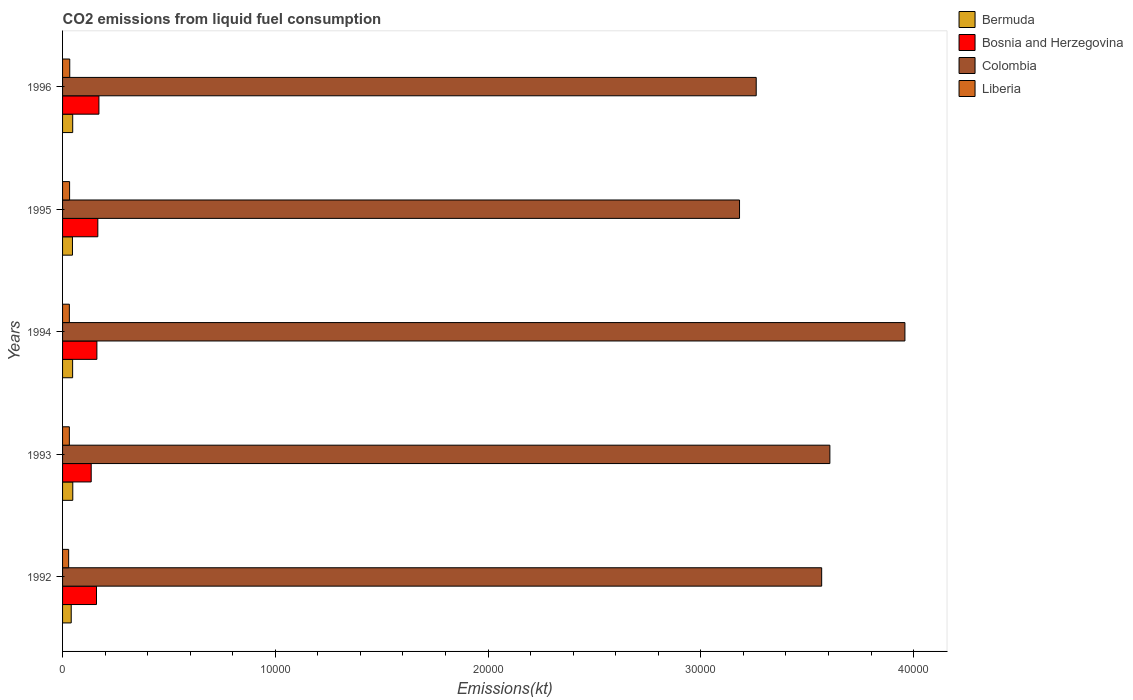How many different coloured bars are there?
Your answer should be compact. 4. How many groups of bars are there?
Your response must be concise. 5. Are the number of bars per tick equal to the number of legend labels?
Provide a succinct answer. Yes. Are the number of bars on each tick of the Y-axis equal?
Your answer should be very brief. Yes. How many bars are there on the 3rd tick from the bottom?
Provide a short and direct response. 4. What is the label of the 4th group of bars from the top?
Your response must be concise. 1993. In how many cases, is the number of bars for a given year not equal to the number of legend labels?
Your answer should be very brief. 0. What is the amount of CO2 emitted in Liberia in 1995?
Ensure brevity in your answer.  330.03. Across all years, what is the maximum amount of CO2 emitted in Colombia?
Give a very brief answer. 3.96e+04. Across all years, what is the minimum amount of CO2 emitted in Liberia?
Provide a succinct answer. 286.03. What is the total amount of CO2 emitted in Bermuda in the graph?
Give a very brief answer. 2302.88. What is the difference between the amount of CO2 emitted in Bermuda in 1994 and that in 1996?
Offer a very short reply. -3.67. What is the difference between the amount of CO2 emitted in Colombia in 1994 and the amount of CO2 emitted in Bosnia and Herzegovina in 1996?
Provide a short and direct response. 3.79e+04. What is the average amount of CO2 emitted in Liberia per year?
Your answer should be very brief. 318.3. In the year 1992, what is the difference between the amount of CO2 emitted in Bosnia and Herzegovina and amount of CO2 emitted in Liberia?
Offer a terse response. 1309.12. What is the ratio of the amount of CO2 emitted in Bosnia and Herzegovina in 1992 to that in 1994?
Offer a very short reply. 0.99. Is the amount of CO2 emitted in Liberia in 1993 less than that in 1996?
Ensure brevity in your answer.  Yes. Is the difference between the amount of CO2 emitted in Bosnia and Herzegovina in 1993 and 1994 greater than the difference between the amount of CO2 emitted in Liberia in 1993 and 1994?
Your response must be concise. No. What is the difference between the highest and the second highest amount of CO2 emitted in Colombia?
Make the answer very short. 3527.65. What is the difference between the highest and the lowest amount of CO2 emitted in Liberia?
Provide a short and direct response. 51.34. In how many years, is the amount of CO2 emitted in Liberia greater than the average amount of CO2 emitted in Liberia taken over all years?
Ensure brevity in your answer.  4. What does the 1st bar from the top in 1994 represents?
Your answer should be compact. Liberia. What does the 2nd bar from the bottom in 1993 represents?
Your answer should be compact. Bosnia and Herzegovina. How many bars are there?
Your answer should be very brief. 20. Are all the bars in the graph horizontal?
Provide a succinct answer. Yes. What is the difference between two consecutive major ticks on the X-axis?
Ensure brevity in your answer.  10000. Are the values on the major ticks of X-axis written in scientific E-notation?
Provide a succinct answer. No. Does the graph contain any zero values?
Your answer should be very brief. No. How are the legend labels stacked?
Offer a terse response. Vertical. What is the title of the graph?
Make the answer very short. CO2 emissions from liquid fuel consumption. Does "Togo" appear as one of the legend labels in the graph?
Offer a very short reply. No. What is the label or title of the X-axis?
Your response must be concise. Emissions(kt). What is the Emissions(kt) of Bermuda in 1992?
Offer a terse response. 407.04. What is the Emissions(kt) in Bosnia and Herzegovina in 1992?
Your answer should be compact. 1595.14. What is the Emissions(kt) of Colombia in 1992?
Keep it short and to the point. 3.57e+04. What is the Emissions(kt) of Liberia in 1992?
Ensure brevity in your answer.  286.03. What is the Emissions(kt) of Bermuda in 1993?
Your response must be concise. 480.38. What is the Emissions(kt) in Bosnia and Herzegovina in 1993?
Make the answer very short. 1345.79. What is the Emissions(kt) in Colombia in 1993?
Provide a short and direct response. 3.61e+04. What is the Emissions(kt) in Liberia in 1993?
Your response must be concise. 319.03. What is the Emissions(kt) of Bermuda in 1994?
Give a very brief answer. 473.04. What is the Emissions(kt) of Bosnia and Herzegovina in 1994?
Give a very brief answer. 1613.48. What is the Emissions(kt) in Colombia in 1994?
Offer a very short reply. 3.96e+04. What is the Emissions(kt) in Liberia in 1994?
Your answer should be compact. 319.03. What is the Emissions(kt) of Bermuda in 1995?
Provide a short and direct response. 465.71. What is the Emissions(kt) of Bosnia and Herzegovina in 1995?
Offer a very short reply. 1657.48. What is the Emissions(kt) of Colombia in 1995?
Provide a short and direct response. 3.18e+04. What is the Emissions(kt) in Liberia in 1995?
Make the answer very short. 330.03. What is the Emissions(kt) of Bermuda in 1996?
Make the answer very short. 476.71. What is the Emissions(kt) of Bosnia and Herzegovina in 1996?
Provide a short and direct response. 1708.82. What is the Emissions(kt) of Colombia in 1996?
Make the answer very short. 3.26e+04. What is the Emissions(kt) of Liberia in 1996?
Offer a terse response. 337.36. Across all years, what is the maximum Emissions(kt) of Bermuda?
Offer a terse response. 480.38. Across all years, what is the maximum Emissions(kt) of Bosnia and Herzegovina?
Keep it short and to the point. 1708.82. Across all years, what is the maximum Emissions(kt) in Colombia?
Ensure brevity in your answer.  3.96e+04. Across all years, what is the maximum Emissions(kt) in Liberia?
Provide a succinct answer. 337.36. Across all years, what is the minimum Emissions(kt) in Bermuda?
Provide a succinct answer. 407.04. Across all years, what is the minimum Emissions(kt) of Bosnia and Herzegovina?
Keep it short and to the point. 1345.79. Across all years, what is the minimum Emissions(kt) in Colombia?
Provide a succinct answer. 3.18e+04. Across all years, what is the minimum Emissions(kt) in Liberia?
Your answer should be very brief. 286.03. What is the total Emissions(kt) in Bermuda in the graph?
Provide a succinct answer. 2302.88. What is the total Emissions(kt) of Bosnia and Herzegovina in the graph?
Provide a succinct answer. 7920.72. What is the total Emissions(kt) of Colombia in the graph?
Offer a terse response. 1.76e+05. What is the total Emissions(kt) of Liberia in the graph?
Make the answer very short. 1591.48. What is the difference between the Emissions(kt) of Bermuda in 1992 and that in 1993?
Your response must be concise. -73.34. What is the difference between the Emissions(kt) of Bosnia and Herzegovina in 1992 and that in 1993?
Offer a very short reply. 249.36. What is the difference between the Emissions(kt) of Colombia in 1992 and that in 1993?
Your answer should be very brief. -385.04. What is the difference between the Emissions(kt) of Liberia in 1992 and that in 1993?
Your response must be concise. -33. What is the difference between the Emissions(kt) in Bermuda in 1992 and that in 1994?
Your answer should be very brief. -66.01. What is the difference between the Emissions(kt) in Bosnia and Herzegovina in 1992 and that in 1994?
Give a very brief answer. -18.34. What is the difference between the Emissions(kt) in Colombia in 1992 and that in 1994?
Ensure brevity in your answer.  -3912.69. What is the difference between the Emissions(kt) in Liberia in 1992 and that in 1994?
Your answer should be compact. -33. What is the difference between the Emissions(kt) in Bermuda in 1992 and that in 1995?
Provide a short and direct response. -58.67. What is the difference between the Emissions(kt) in Bosnia and Herzegovina in 1992 and that in 1995?
Offer a terse response. -62.34. What is the difference between the Emissions(kt) of Colombia in 1992 and that in 1995?
Make the answer very short. 3861.35. What is the difference between the Emissions(kt) in Liberia in 1992 and that in 1995?
Offer a terse response. -44. What is the difference between the Emissions(kt) in Bermuda in 1992 and that in 1996?
Your answer should be compact. -69.67. What is the difference between the Emissions(kt) in Bosnia and Herzegovina in 1992 and that in 1996?
Your answer should be very brief. -113.68. What is the difference between the Emissions(kt) of Colombia in 1992 and that in 1996?
Keep it short and to the point. 3076.61. What is the difference between the Emissions(kt) of Liberia in 1992 and that in 1996?
Offer a very short reply. -51.34. What is the difference between the Emissions(kt) of Bermuda in 1993 and that in 1994?
Keep it short and to the point. 7.33. What is the difference between the Emissions(kt) of Bosnia and Herzegovina in 1993 and that in 1994?
Offer a terse response. -267.69. What is the difference between the Emissions(kt) of Colombia in 1993 and that in 1994?
Your answer should be very brief. -3527.65. What is the difference between the Emissions(kt) of Liberia in 1993 and that in 1994?
Your answer should be very brief. 0. What is the difference between the Emissions(kt) in Bermuda in 1993 and that in 1995?
Keep it short and to the point. 14.67. What is the difference between the Emissions(kt) in Bosnia and Herzegovina in 1993 and that in 1995?
Your answer should be very brief. -311.69. What is the difference between the Emissions(kt) of Colombia in 1993 and that in 1995?
Offer a terse response. 4246.39. What is the difference between the Emissions(kt) of Liberia in 1993 and that in 1995?
Offer a very short reply. -11. What is the difference between the Emissions(kt) in Bermuda in 1993 and that in 1996?
Offer a terse response. 3.67. What is the difference between the Emissions(kt) in Bosnia and Herzegovina in 1993 and that in 1996?
Ensure brevity in your answer.  -363.03. What is the difference between the Emissions(kt) of Colombia in 1993 and that in 1996?
Offer a very short reply. 3461.65. What is the difference between the Emissions(kt) in Liberia in 1993 and that in 1996?
Your answer should be very brief. -18.34. What is the difference between the Emissions(kt) in Bermuda in 1994 and that in 1995?
Make the answer very short. 7.33. What is the difference between the Emissions(kt) in Bosnia and Herzegovina in 1994 and that in 1995?
Ensure brevity in your answer.  -44. What is the difference between the Emissions(kt) in Colombia in 1994 and that in 1995?
Provide a short and direct response. 7774.04. What is the difference between the Emissions(kt) in Liberia in 1994 and that in 1995?
Keep it short and to the point. -11. What is the difference between the Emissions(kt) in Bermuda in 1994 and that in 1996?
Your response must be concise. -3.67. What is the difference between the Emissions(kt) in Bosnia and Herzegovina in 1994 and that in 1996?
Your answer should be very brief. -95.34. What is the difference between the Emissions(kt) in Colombia in 1994 and that in 1996?
Ensure brevity in your answer.  6989.3. What is the difference between the Emissions(kt) in Liberia in 1994 and that in 1996?
Provide a succinct answer. -18.34. What is the difference between the Emissions(kt) in Bermuda in 1995 and that in 1996?
Your answer should be compact. -11. What is the difference between the Emissions(kt) of Bosnia and Herzegovina in 1995 and that in 1996?
Give a very brief answer. -51.34. What is the difference between the Emissions(kt) of Colombia in 1995 and that in 1996?
Your answer should be compact. -784.74. What is the difference between the Emissions(kt) of Liberia in 1995 and that in 1996?
Your answer should be very brief. -7.33. What is the difference between the Emissions(kt) in Bermuda in 1992 and the Emissions(kt) in Bosnia and Herzegovina in 1993?
Your response must be concise. -938.75. What is the difference between the Emissions(kt) of Bermuda in 1992 and the Emissions(kt) of Colombia in 1993?
Your answer should be compact. -3.57e+04. What is the difference between the Emissions(kt) in Bermuda in 1992 and the Emissions(kt) in Liberia in 1993?
Offer a terse response. 88.01. What is the difference between the Emissions(kt) in Bosnia and Herzegovina in 1992 and the Emissions(kt) in Colombia in 1993?
Offer a very short reply. -3.45e+04. What is the difference between the Emissions(kt) of Bosnia and Herzegovina in 1992 and the Emissions(kt) of Liberia in 1993?
Your answer should be very brief. 1276.12. What is the difference between the Emissions(kt) of Colombia in 1992 and the Emissions(kt) of Liberia in 1993?
Offer a very short reply. 3.54e+04. What is the difference between the Emissions(kt) of Bermuda in 1992 and the Emissions(kt) of Bosnia and Herzegovina in 1994?
Make the answer very short. -1206.44. What is the difference between the Emissions(kt) of Bermuda in 1992 and the Emissions(kt) of Colombia in 1994?
Provide a short and direct response. -3.92e+04. What is the difference between the Emissions(kt) in Bermuda in 1992 and the Emissions(kt) in Liberia in 1994?
Offer a terse response. 88.01. What is the difference between the Emissions(kt) of Bosnia and Herzegovina in 1992 and the Emissions(kt) of Colombia in 1994?
Ensure brevity in your answer.  -3.80e+04. What is the difference between the Emissions(kt) in Bosnia and Herzegovina in 1992 and the Emissions(kt) in Liberia in 1994?
Your response must be concise. 1276.12. What is the difference between the Emissions(kt) of Colombia in 1992 and the Emissions(kt) of Liberia in 1994?
Provide a short and direct response. 3.54e+04. What is the difference between the Emissions(kt) of Bermuda in 1992 and the Emissions(kt) of Bosnia and Herzegovina in 1995?
Make the answer very short. -1250.45. What is the difference between the Emissions(kt) of Bermuda in 1992 and the Emissions(kt) of Colombia in 1995?
Give a very brief answer. -3.14e+04. What is the difference between the Emissions(kt) of Bermuda in 1992 and the Emissions(kt) of Liberia in 1995?
Your answer should be compact. 77.01. What is the difference between the Emissions(kt) of Bosnia and Herzegovina in 1992 and the Emissions(kt) of Colombia in 1995?
Your answer should be compact. -3.02e+04. What is the difference between the Emissions(kt) of Bosnia and Herzegovina in 1992 and the Emissions(kt) of Liberia in 1995?
Offer a terse response. 1265.12. What is the difference between the Emissions(kt) of Colombia in 1992 and the Emissions(kt) of Liberia in 1995?
Offer a very short reply. 3.53e+04. What is the difference between the Emissions(kt) in Bermuda in 1992 and the Emissions(kt) in Bosnia and Herzegovina in 1996?
Provide a short and direct response. -1301.79. What is the difference between the Emissions(kt) in Bermuda in 1992 and the Emissions(kt) in Colombia in 1996?
Keep it short and to the point. -3.22e+04. What is the difference between the Emissions(kt) of Bermuda in 1992 and the Emissions(kt) of Liberia in 1996?
Give a very brief answer. 69.67. What is the difference between the Emissions(kt) of Bosnia and Herzegovina in 1992 and the Emissions(kt) of Colombia in 1996?
Your answer should be very brief. -3.10e+04. What is the difference between the Emissions(kt) of Bosnia and Herzegovina in 1992 and the Emissions(kt) of Liberia in 1996?
Provide a short and direct response. 1257.78. What is the difference between the Emissions(kt) of Colombia in 1992 and the Emissions(kt) of Liberia in 1996?
Your answer should be compact. 3.53e+04. What is the difference between the Emissions(kt) of Bermuda in 1993 and the Emissions(kt) of Bosnia and Herzegovina in 1994?
Offer a terse response. -1133.1. What is the difference between the Emissions(kt) of Bermuda in 1993 and the Emissions(kt) of Colombia in 1994?
Your response must be concise. -3.91e+04. What is the difference between the Emissions(kt) in Bermuda in 1993 and the Emissions(kt) in Liberia in 1994?
Offer a very short reply. 161.35. What is the difference between the Emissions(kt) in Bosnia and Herzegovina in 1993 and the Emissions(kt) in Colombia in 1994?
Provide a succinct answer. -3.82e+04. What is the difference between the Emissions(kt) in Bosnia and Herzegovina in 1993 and the Emissions(kt) in Liberia in 1994?
Provide a succinct answer. 1026.76. What is the difference between the Emissions(kt) in Colombia in 1993 and the Emissions(kt) in Liberia in 1994?
Keep it short and to the point. 3.57e+04. What is the difference between the Emissions(kt) in Bermuda in 1993 and the Emissions(kt) in Bosnia and Herzegovina in 1995?
Offer a terse response. -1177.11. What is the difference between the Emissions(kt) of Bermuda in 1993 and the Emissions(kt) of Colombia in 1995?
Your answer should be compact. -3.13e+04. What is the difference between the Emissions(kt) in Bermuda in 1993 and the Emissions(kt) in Liberia in 1995?
Provide a succinct answer. 150.35. What is the difference between the Emissions(kt) of Bosnia and Herzegovina in 1993 and the Emissions(kt) of Colombia in 1995?
Give a very brief answer. -3.05e+04. What is the difference between the Emissions(kt) in Bosnia and Herzegovina in 1993 and the Emissions(kt) in Liberia in 1995?
Offer a very short reply. 1015.76. What is the difference between the Emissions(kt) in Colombia in 1993 and the Emissions(kt) in Liberia in 1995?
Provide a short and direct response. 3.57e+04. What is the difference between the Emissions(kt) of Bermuda in 1993 and the Emissions(kt) of Bosnia and Herzegovina in 1996?
Provide a succinct answer. -1228.44. What is the difference between the Emissions(kt) of Bermuda in 1993 and the Emissions(kt) of Colombia in 1996?
Your answer should be compact. -3.21e+04. What is the difference between the Emissions(kt) in Bermuda in 1993 and the Emissions(kt) in Liberia in 1996?
Keep it short and to the point. 143.01. What is the difference between the Emissions(kt) in Bosnia and Herzegovina in 1993 and the Emissions(kt) in Colombia in 1996?
Ensure brevity in your answer.  -3.13e+04. What is the difference between the Emissions(kt) of Bosnia and Herzegovina in 1993 and the Emissions(kt) of Liberia in 1996?
Give a very brief answer. 1008.42. What is the difference between the Emissions(kt) of Colombia in 1993 and the Emissions(kt) of Liberia in 1996?
Keep it short and to the point. 3.57e+04. What is the difference between the Emissions(kt) of Bermuda in 1994 and the Emissions(kt) of Bosnia and Herzegovina in 1995?
Offer a terse response. -1184.44. What is the difference between the Emissions(kt) of Bermuda in 1994 and the Emissions(kt) of Colombia in 1995?
Your answer should be very brief. -3.13e+04. What is the difference between the Emissions(kt) of Bermuda in 1994 and the Emissions(kt) of Liberia in 1995?
Offer a terse response. 143.01. What is the difference between the Emissions(kt) in Bosnia and Herzegovina in 1994 and the Emissions(kt) in Colombia in 1995?
Your answer should be very brief. -3.02e+04. What is the difference between the Emissions(kt) in Bosnia and Herzegovina in 1994 and the Emissions(kt) in Liberia in 1995?
Your answer should be very brief. 1283.45. What is the difference between the Emissions(kt) in Colombia in 1994 and the Emissions(kt) in Liberia in 1995?
Give a very brief answer. 3.93e+04. What is the difference between the Emissions(kt) of Bermuda in 1994 and the Emissions(kt) of Bosnia and Herzegovina in 1996?
Make the answer very short. -1235.78. What is the difference between the Emissions(kt) in Bermuda in 1994 and the Emissions(kt) in Colombia in 1996?
Make the answer very short. -3.21e+04. What is the difference between the Emissions(kt) in Bermuda in 1994 and the Emissions(kt) in Liberia in 1996?
Your response must be concise. 135.68. What is the difference between the Emissions(kt) of Bosnia and Herzegovina in 1994 and the Emissions(kt) of Colombia in 1996?
Offer a very short reply. -3.10e+04. What is the difference between the Emissions(kt) of Bosnia and Herzegovina in 1994 and the Emissions(kt) of Liberia in 1996?
Your answer should be compact. 1276.12. What is the difference between the Emissions(kt) of Colombia in 1994 and the Emissions(kt) of Liberia in 1996?
Your answer should be compact. 3.93e+04. What is the difference between the Emissions(kt) in Bermuda in 1995 and the Emissions(kt) in Bosnia and Herzegovina in 1996?
Make the answer very short. -1243.11. What is the difference between the Emissions(kt) of Bermuda in 1995 and the Emissions(kt) of Colombia in 1996?
Offer a terse response. -3.21e+04. What is the difference between the Emissions(kt) in Bermuda in 1995 and the Emissions(kt) in Liberia in 1996?
Make the answer very short. 128.34. What is the difference between the Emissions(kt) of Bosnia and Herzegovina in 1995 and the Emissions(kt) of Colombia in 1996?
Give a very brief answer. -3.09e+04. What is the difference between the Emissions(kt) of Bosnia and Herzegovina in 1995 and the Emissions(kt) of Liberia in 1996?
Provide a short and direct response. 1320.12. What is the difference between the Emissions(kt) in Colombia in 1995 and the Emissions(kt) in Liberia in 1996?
Provide a short and direct response. 3.15e+04. What is the average Emissions(kt) in Bermuda per year?
Offer a very short reply. 460.58. What is the average Emissions(kt) in Bosnia and Herzegovina per year?
Keep it short and to the point. 1584.14. What is the average Emissions(kt) of Colombia per year?
Ensure brevity in your answer.  3.52e+04. What is the average Emissions(kt) in Liberia per year?
Provide a short and direct response. 318.3. In the year 1992, what is the difference between the Emissions(kt) in Bermuda and Emissions(kt) in Bosnia and Herzegovina?
Give a very brief answer. -1188.11. In the year 1992, what is the difference between the Emissions(kt) in Bermuda and Emissions(kt) in Colombia?
Provide a succinct answer. -3.53e+04. In the year 1992, what is the difference between the Emissions(kt) of Bermuda and Emissions(kt) of Liberia?
Give a very brief answer. 121.01. In the year 1992, what is the difference between the Emissions(kt) in Bosnia and Herzegovina and Emissions(kt) in Colombia?
Give a very brief answer. -3.41e+04. In the year 1992, what is the difference between the Emissions(kt) of Bosnia and Herzegovina and Emissions(kt) of Liberia?
Offer a terse response. 1309.12. In the year 1992, what is the difference between the Emissions(kt) in Colombia and Emissions(kt) in Liberia?
Keep it short and to the point. 3.54e+04. In the year 1993, what is the difference between the Emissions(kt) of Bermuda and Emissions(kt) of Bosnia and Herzegovina?
Your response must be concise. -865.41. In the year 1993, what is the difference between the Emissions(kt) in Bermuda and Emissions(kt) in Colombia?
Your response must be concise. -3.56e+04. In the year 1993, what is the difference between the Emissions(kt) of Bermuda and Emissions(kt) of Liberia?
Give a very brief answer. 161.35. In the year 1993, what is the difference between the Emissions(kt) of Bosnia and Herzegovina and Emissions(kt) of Colombia?
Your answer should be compact. -3.47e+04. In the year 1993, what is the difference between the Emissions(kt) of Bosnia and Herzegovina and Emissions(kt) of Liberia?
Ensure brevity in your answer.  1026.76. In the year 1993, what is the difference between the Emissions(kt) of Colombia and Emissions(kt) of Liberia?
Your answer should be compact. 3.57e+04. In the year 1994, what is the difference between the Emissions(kt) in Bermuda and Emissions(kt) in Bosnia and Herzegovina?
Offer a terse response. -1140.44. In the year 1994, what is the difference between the Emissions(kt) of Bermuda and Emissions(kt) of Colombia?
Offer a terse response. -3.91e+04. In the year 1994, what is the difference between the Emissions(kt) in Bermuda and Emissions(kt) in Liberia?
Your answer should be compact. 154.01. In the year 1994, what is the difference between the Emissions(kt) in Bosnia and Herzegovina and Emissions(kt) in Colombia?
Make the answer very short. -3.80e+04. In the year 1994, what is the difference between the Emissions(kt) of Bosnia and Herzegovina and Emissions(kt) of Liberia?
Provide a short and direct response. 1294.45. In the year 1994, what is the difference between the Emissions(kt) in Colombia and Emissions(kt) in Liberia?
Make the answer very short. 3.93e+04. In the year 1995, what is the difference between the Emissions(kt) of Bermuda and Emissions(kt) of Bosnia and Herzegovina?
Make the answer very short. -1191.78. In the year 1995, what is the difference between the Emissions(kt) in Bermuda and Emissions(kt) in Colombia?
Ensure brevity in your answer.  -3.14e+04. In the year 1995, what is the difference between the Emissions(kt) in Bermuda and Emissions(kt) in Liberia?
Your answer should be very brief. 135.68. In the year 1995, what is the difference between the Emissions(kt) in Bosnia and Herzegovina and Emissions(kt) in Colombia?
Provide a short and direct response. -3.02e+04. In the year 1995, what is the difference between the Emissions(kt) of Bosnia and Herzegovina and Emissions(kt) of Liberia?
Keep it short and to the point. 1327.45. In the year 1995, what is the difference between the Emissions(kt) of Colombia and Emissions(kt) of Liberia?
Provide a short and direct response. 3.15e+04. In the year 1996, what is the difference between the Emissions(kt) in Bermuda and Emissions(kt) in Bosnia and Herzegovina?
Keep it short and to the point. -1232.11. In the year 1996, what is the difference between the Emissions(kt) in Bermuda and Emissions(kt) in Colombia?
Provide a short and direct response. -3.21e+04. In the year 1996, what is the difference between the Emissions(kt) in Bermuda and Emissions(kt) in Liberia?
Keep it short and to the point. 139.35. In the year 1996, what is the difference between the Emissions(kt) of Bosnia and Herzegovina and Emissions(kt) of Colombia?
Ensure brevity in your answer.  -3.09e+04. In the year 1996, what is the difference between the Emissions(kt) in Bosnia and Herzegovina and Emissions(kt) in Liberia?
Give a very brief answer. 1371.46. In the year 1996, what is the difference between the Emissions(kt) of Colombia and Emissions(kt) of Liberia?
Provide a short and direct response. 3.23e+04. What is the ratio of the Emissions(kt) in Bermuda in 1992 to that in 1993?
Provide a short and direct response. 0.85. What is the ratio of the Emissions(kt) of Bosnia and Herzegovina in 1992 to that in 1993?
Provide a short and direct response. 1.19. What is the ratio of the Emissions(kt) in Colombia in 1992 to that in 1993?
Make the answer very short. 0.99. What is the ratio of the Emissions(kt) of Liberia in 1992 to that in 1993?
Keep it short and to the point. 0.9. What is the ratio of the Emissions(kt) of Bermuda in 1992 to that in 1994?
Offer a very short reply. 0.86. What is the ratio of the Emissions(kt) in Bosnia and Herzegovina in 1992 to that in 1994?
Ensure brevity in your answer.  0.99. What is the ratio of the Emissions(kt) in Colombia in 1992 to that in 1994?
Your answer should be compact. 0.9. What is the ratio of the Emissions(kt) of Liberia in 1992 to that in 1994?
Keep it short and to the point. 0.9. What is the ratio of the Emissions(kt) of Bermuda in 1992 to that in 1995?
Your response must be concise. 0.87. What is the ratio of the Emissions(kt) in Bosnia and Herzegovina in 1992 to that in 1995?
Your answer should be compact. 0.96. What is the ratio of the Emissions(kt) of Colombia in 1992 to that in 1995?
Your answer should be compact. 1.12. What is the ratio of the Emissions(kt) of Liberia in 1992 to that in 1995?
Ensure brevity in your answer.  0.87. What is the ratio of the Emissions(kt) in Bermuda in 1992 to that in 1996?
Provide a succinct answer. 0.85. What is the ratio of the Emissions(kt) in Bosnia and Herzegovina in 1992 to that in 1996?
Offer a very short reply. 0.93. What is the ratio of the Emissions(kt) in Colombia in 1992 to that in 1996?
Make the answer very short. 1.09. What is the ratio of the Emissions(kt) in Liberia in 1992 to that in 1996?
Your answer should be very brief. 0.85. What is the ratio of the Emissions(kt) in Bermuda in 1993 to that in 1994?
Make the answer very short. 1.02. What is the ratio of the Emissions(kt) in Bosnia and Herzegovina in 1993 to that in 1994?
Provide a short and direct response. 0.83. What is the ratio of the Emissions(kt) in Colombia in 1993 to that in 1994?
Your answer should be very brief. 0.91. What is the ratio of the Emissions(kt) in Liberia in 1993 to that in 1994?
Make the answer very short. 1. What is the ratio of the Emissions(kt) in Bermuda in 1993 to that in 1995?
Your answer should be very brief. 1.03. What is the ratio of the Emissions(kt) in Bosnia and Herzegovina in 1993 to that in 1995?
Provide a short and direct response. 0.81. What is the ratio of the Emissions(kt) in Colombia in 1993 to that in 1995?
Your answer should be very brief. 1.13. What is the ratio of the Emissions(kt) of Liberia in 1993 to that in 1995?
Give a very brief answer. 0.97. What is the ratio of the Emissions(kt) in Bermuda in 1993 to that in 1996?
Provide a short and direct response. 1.01. What is the ratio of the Emissions(kt) of Bosnia and Herzegovina in 1993 to that in 1996?
Provide a short and direct response. 0.79. What is the ratio of the Emissions(kt) in Colombia in 1993 to that in 1996?
Give a very brief answer. 1.11. What is the ratio of the Emissions(kt) of Liberia in 1993 to that in 1996?
Provide a short and direct response. 0.95. What is the ratio of the Emissions(kt) of Bermuda in 1994 to that in 1995?
Make the answer very short. 1.02. What is the ratio of the Emissions(kt) of Bosnia and Herzegovina in 1994 to that in 1995?
Make the answer very short. 0.97. What is the ratio of the Emissions(kt) of Colombia in 1994 to that in 1995?
Offer a very short reply. 1.24. What is the ratio of the Emissions(kt) of Liberia in 1994 to that in 1995?
Make the answer very short. 0.97. What is the ratio of the Emissions(kt) of Bosnia and Herzegovina in 1994 to that in 1996?
Your answer should be very brief. 0.94. What is the ratio of the Emissions(kt) of Colombia in 1994 to that in 1996?
Your answer should be very brief. 1.21. What is the ratio of the Emissions(kt) in Liberia in 1994 to that in 1996?
Your answer should be compact. 0.95. What is the ratio of the Emissions(kt) in Bermuda in 1995 to that in 1996?
Make the answer very short. 0.98. What is the ratio of the Emissions(kt) of Colombia in 1995 to that in 1996?
Offer a terse response. 0.98. What is the ratio of the Emissions(kt) in Liberia in 1995 to that in 1996?
Provide a succinct answer. 0.98. What is the difference between the highest and the second highest Emissions(kt) in Bermuda?
Ensure brevity in your answer.  3.67. What is the difference between the highest and the second highest Emissions(kt) of Bosnia and Herzegovina?
Ensure brevity in your answer.  51.34. What is the difference between the highest and the second highest Emissions(kt) in Colombia?
Ensure brevity in your answer.  3527.65. What is the difference between the highest and the second highest Emissions(kt) in Liberia?
Your answer should be very brief. 7.33. What is the difference between the highest and the lowest Emissions(kt) in Bermuda?
Your response must be concise. 73.34. What is the difference between the highest and the lowest Emissions(kt) in Bosnia and Herzegovina?
Provide a short and direct response. 363.03. What is the difference between the highest and the lowest Emissions(kt) of Colombia?
Ensure brevity in your answer.  7774.04. What is the difference between the highest and the lowest Emissions(kt) in Liberia?
Make the answer very short. 51.34. 